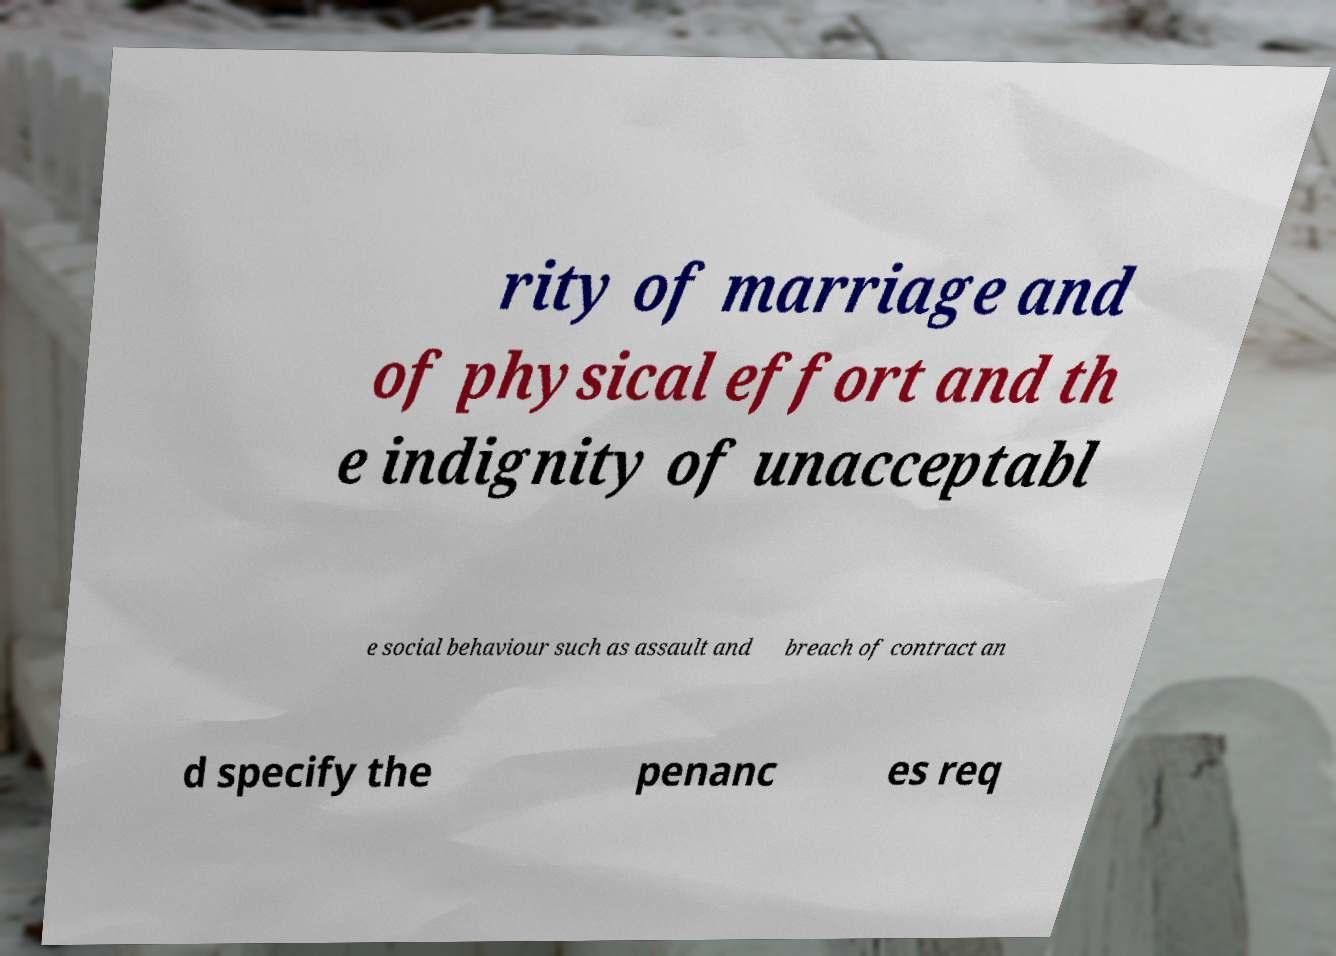There's text embedded in this image that I need extracted. Can you transcribe it verbatim? rity of marriage and of physical effort and th e indignity of unacceptabl e social behaviour such as assault and breach of contract an d specify the penanc es req 